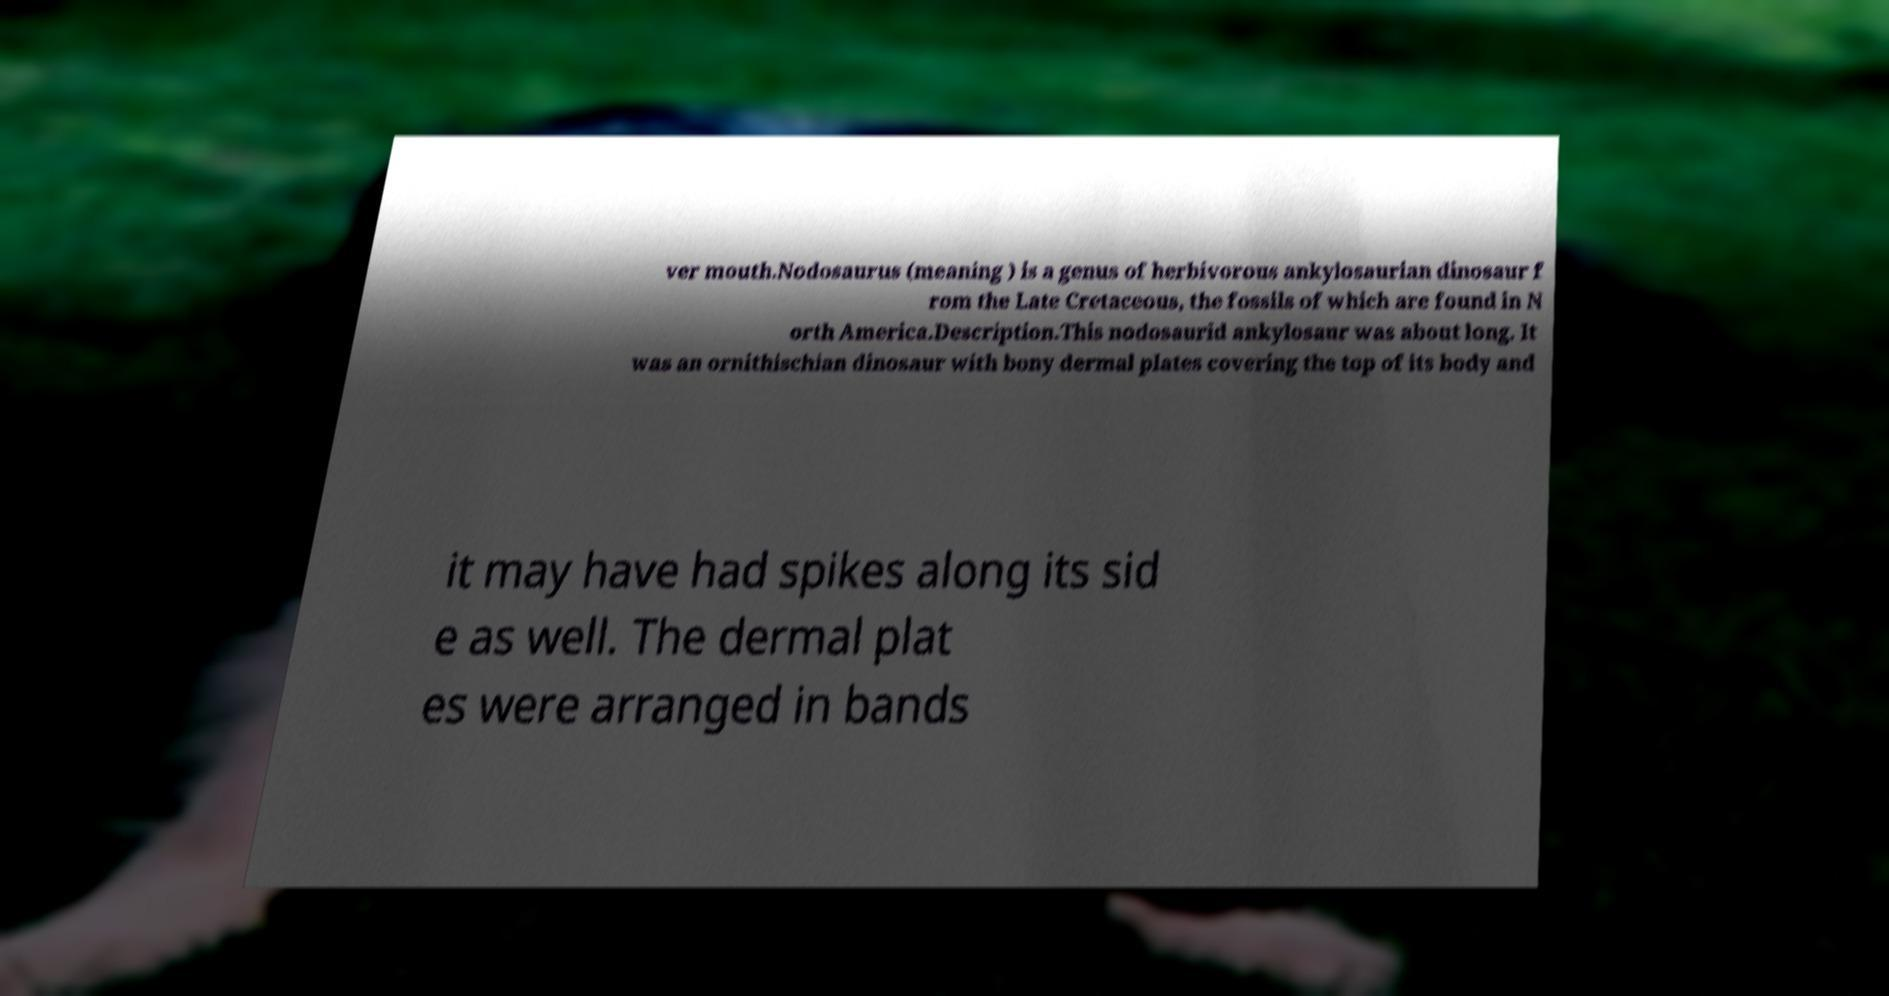Could you extract and type out the text from this image? ver mouth.Nodosaurus (meaning ) is a genus of herbivorous ankylosaurian dinosaur f rom the Late Cretaceous, the fossils of which are found in N orth America.Description.This nodosaurid ankylosaur was about long. It was an ornithischian dinosaur with bony dermal plates covering the top of its body and it may have had spikes along its sid e as well. The dermal plat es were arranged in bands 